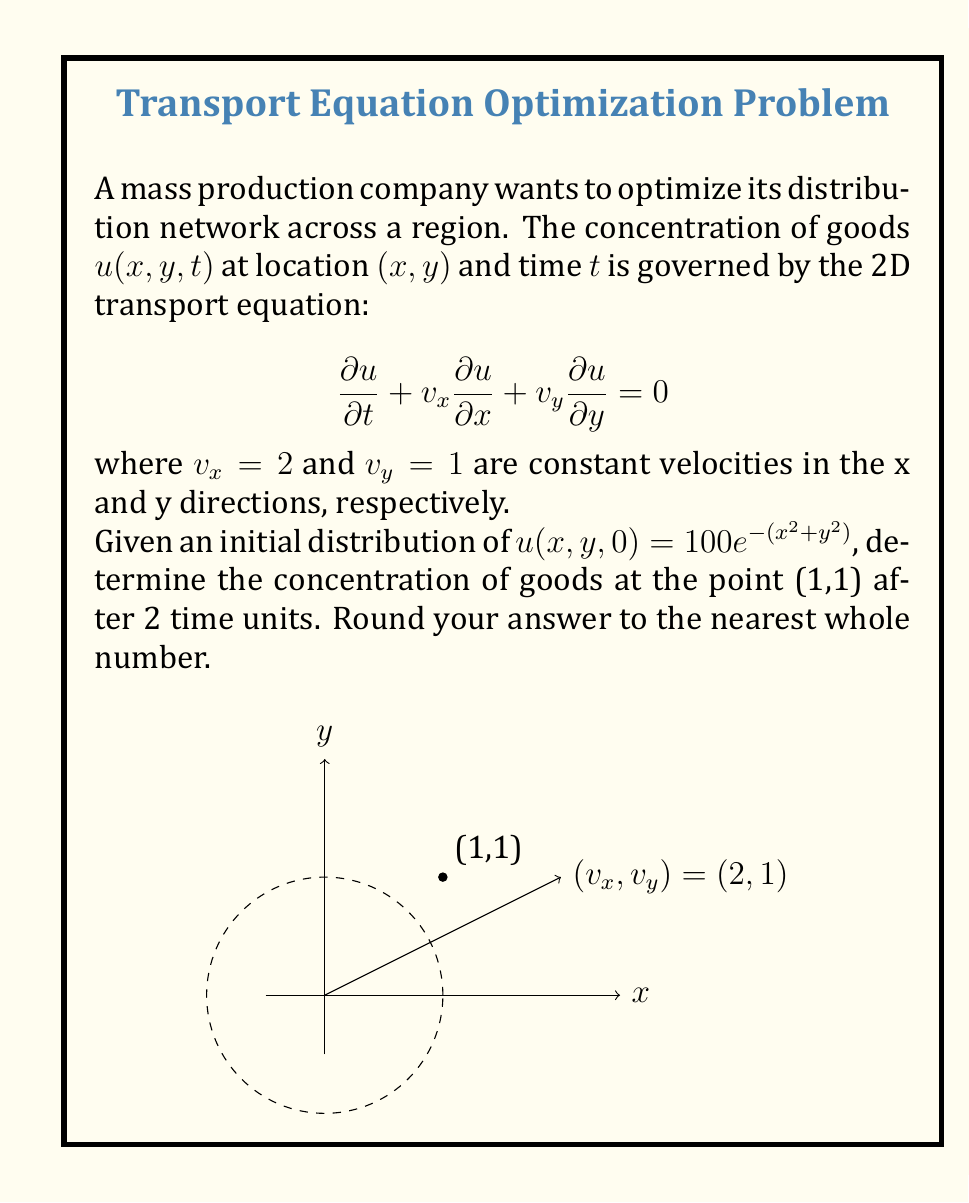What is the answer to this math problem? To solve this problem, we'll follow these steps:

1) The general solution to the 2D transport equation is:

   $$u(x,y,t) = u_0(x-v_xt, y-v_yt)$$

   where $u_0(x,y)$ is the initial distribution.

2) In our case, $u_0(x,y) = 100e^{-(x^2+y^2)}$, $v_x = 2$, and $v_y = 1$.

3) We want to find $u(1,1,2)$, so we substitute these values:

   $$u(1,1,2) = u_0(1-2\cdot2, 1-1\cdot2)$$

4) Simplify:

   $$u(1,1,2) = u_0(-3,-1)$$

5) Now substitute into the initial distribution function:

   $$u(1,1,2) = 100e^{-((-3)^2+(-1)^2)}$$

6) Simplify:

   $$u(1,1,2) = 100e^{-(9+1)} = 100e^{-10}$$

7) Calculate this value:

   $$u(1,1,2) = 100 \cdot (e^{-10}) \approx 4.54$$

8) Rounding to the nearest whole number:

   $$u(1,1,2) \approx 5$$
Answer: 5 